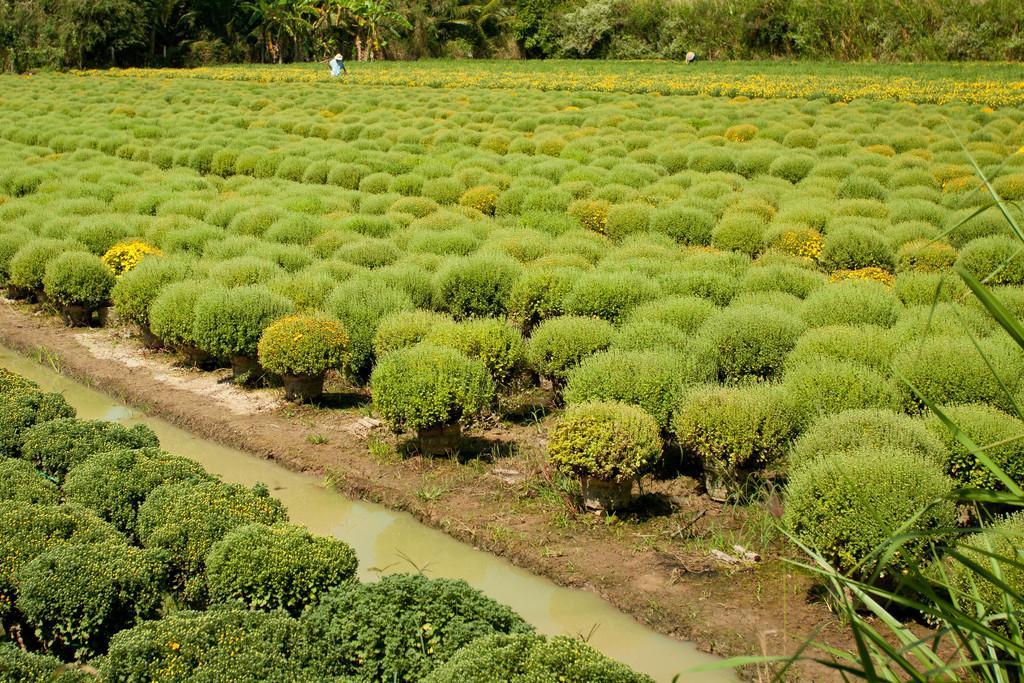Could you give a brief overview of what you see in this image? This image consists of many potted plants. In the middle, we can see the water on the ground. In the background, there are trees. And there is a human in the middle. 